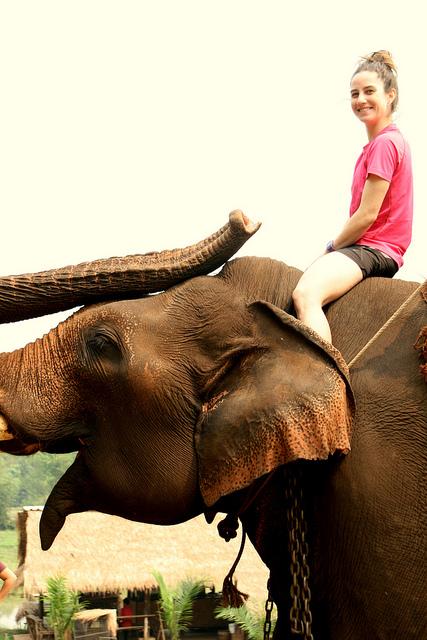Is this animal at home in mountainous areas?
Concise answer only. No. What is the elephant doing with its trunk?
Short answer required. Playing. Does the woman appear to be a tourist or an animal trainer?
Answer briefly. Tourist. What kind of hairstyle is the woman wearing?
Give a very brief answer. Ponytail. 